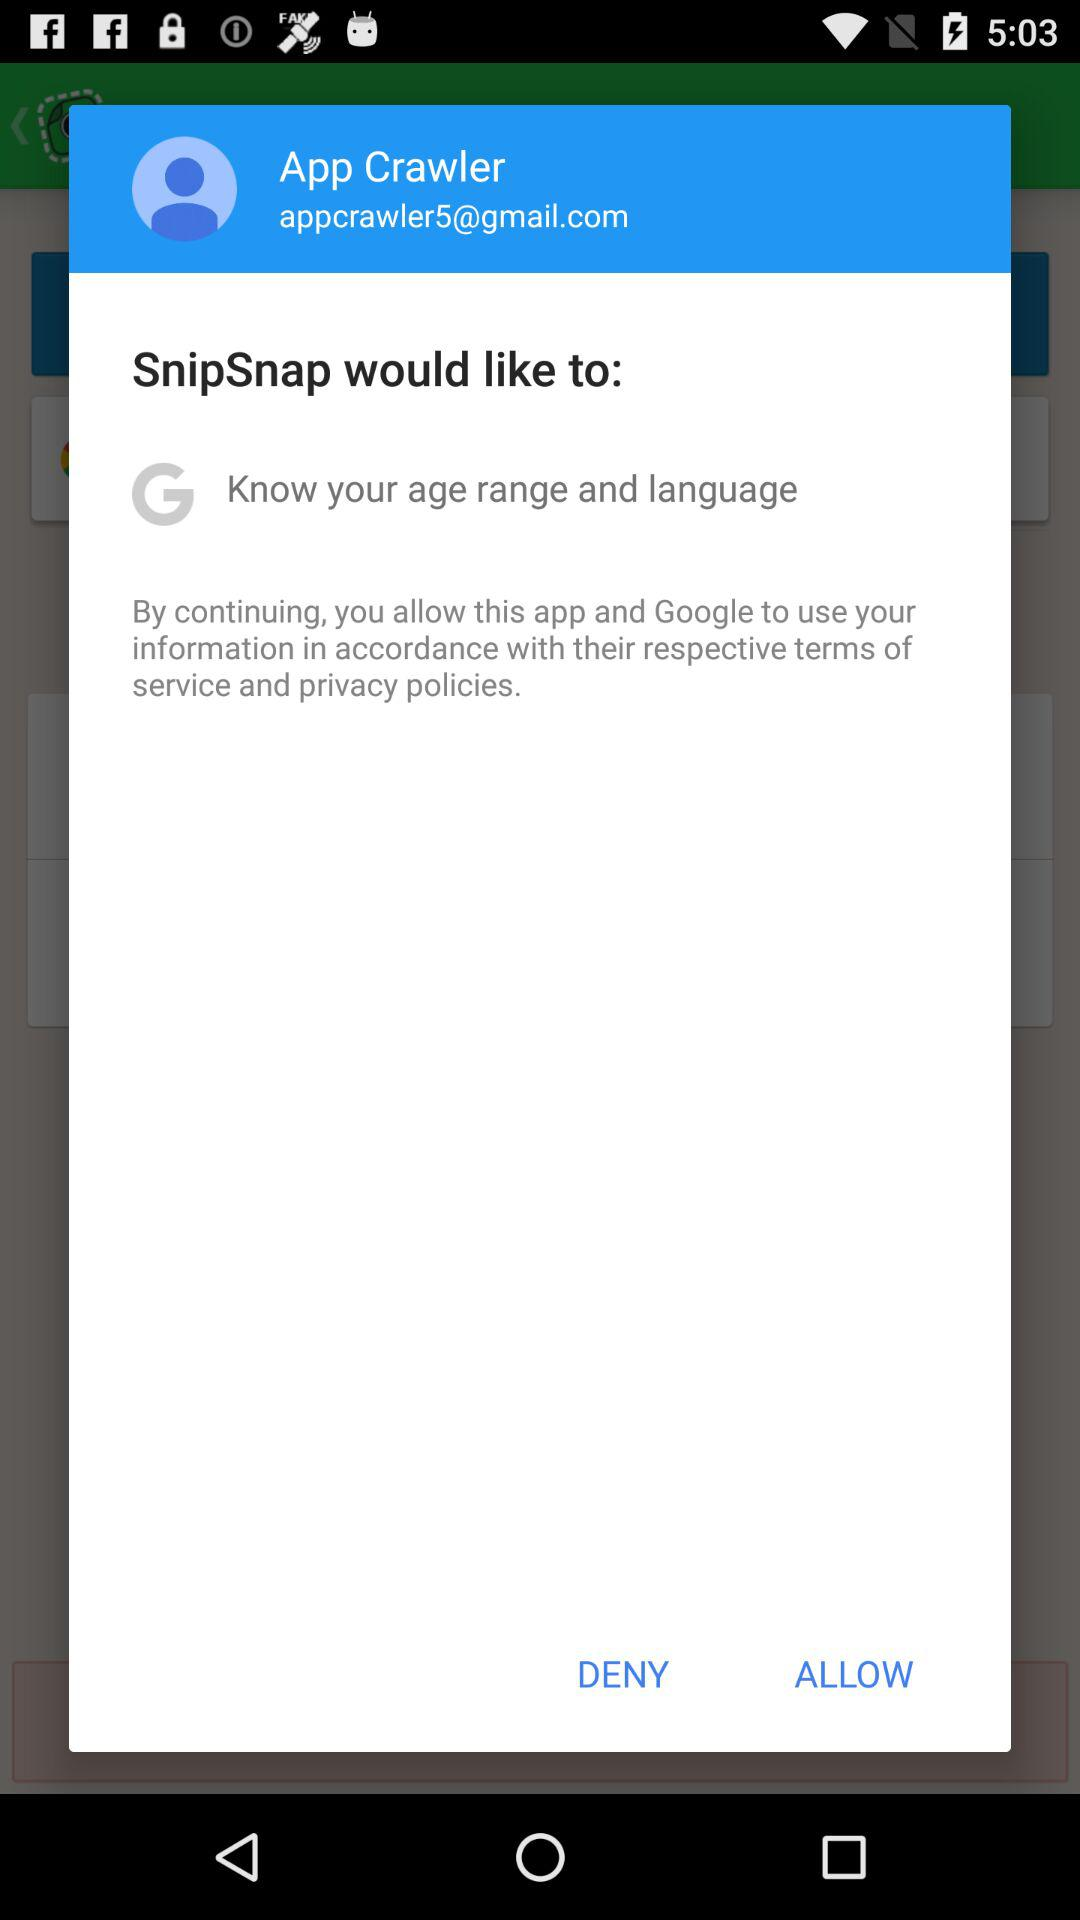What is the name of the user? The name of the user is App Crawler. 